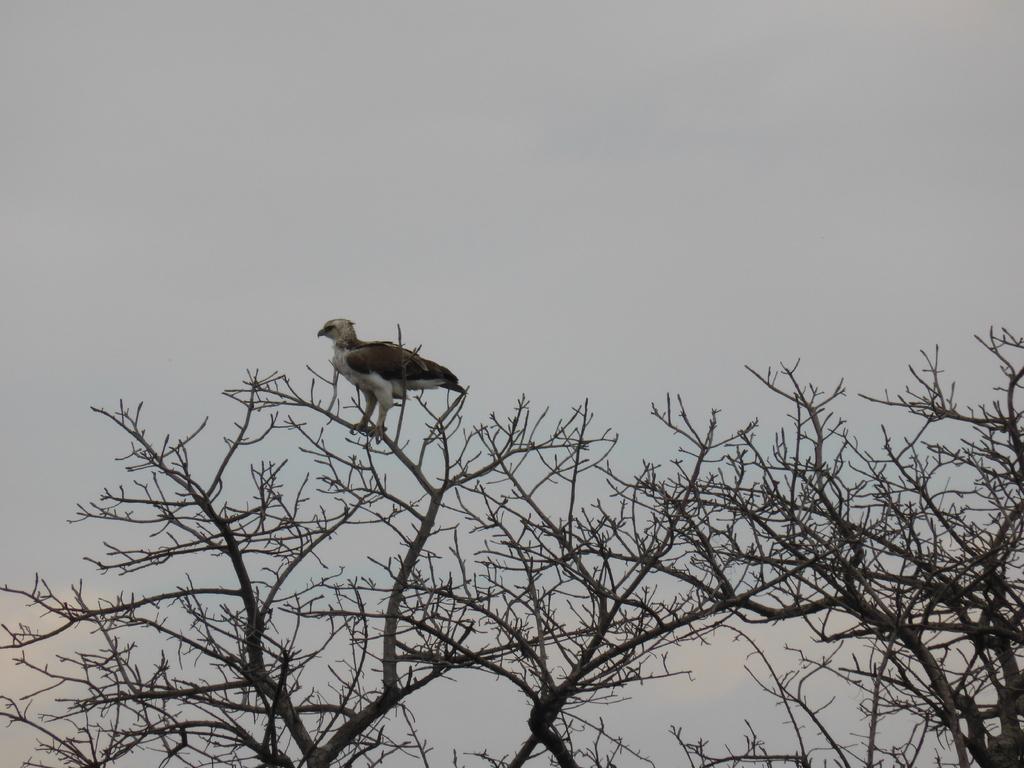Please provide a concise description of this image. In this image I can see the bird on the dried tree. In the background I can see the sky in blue and white color. 